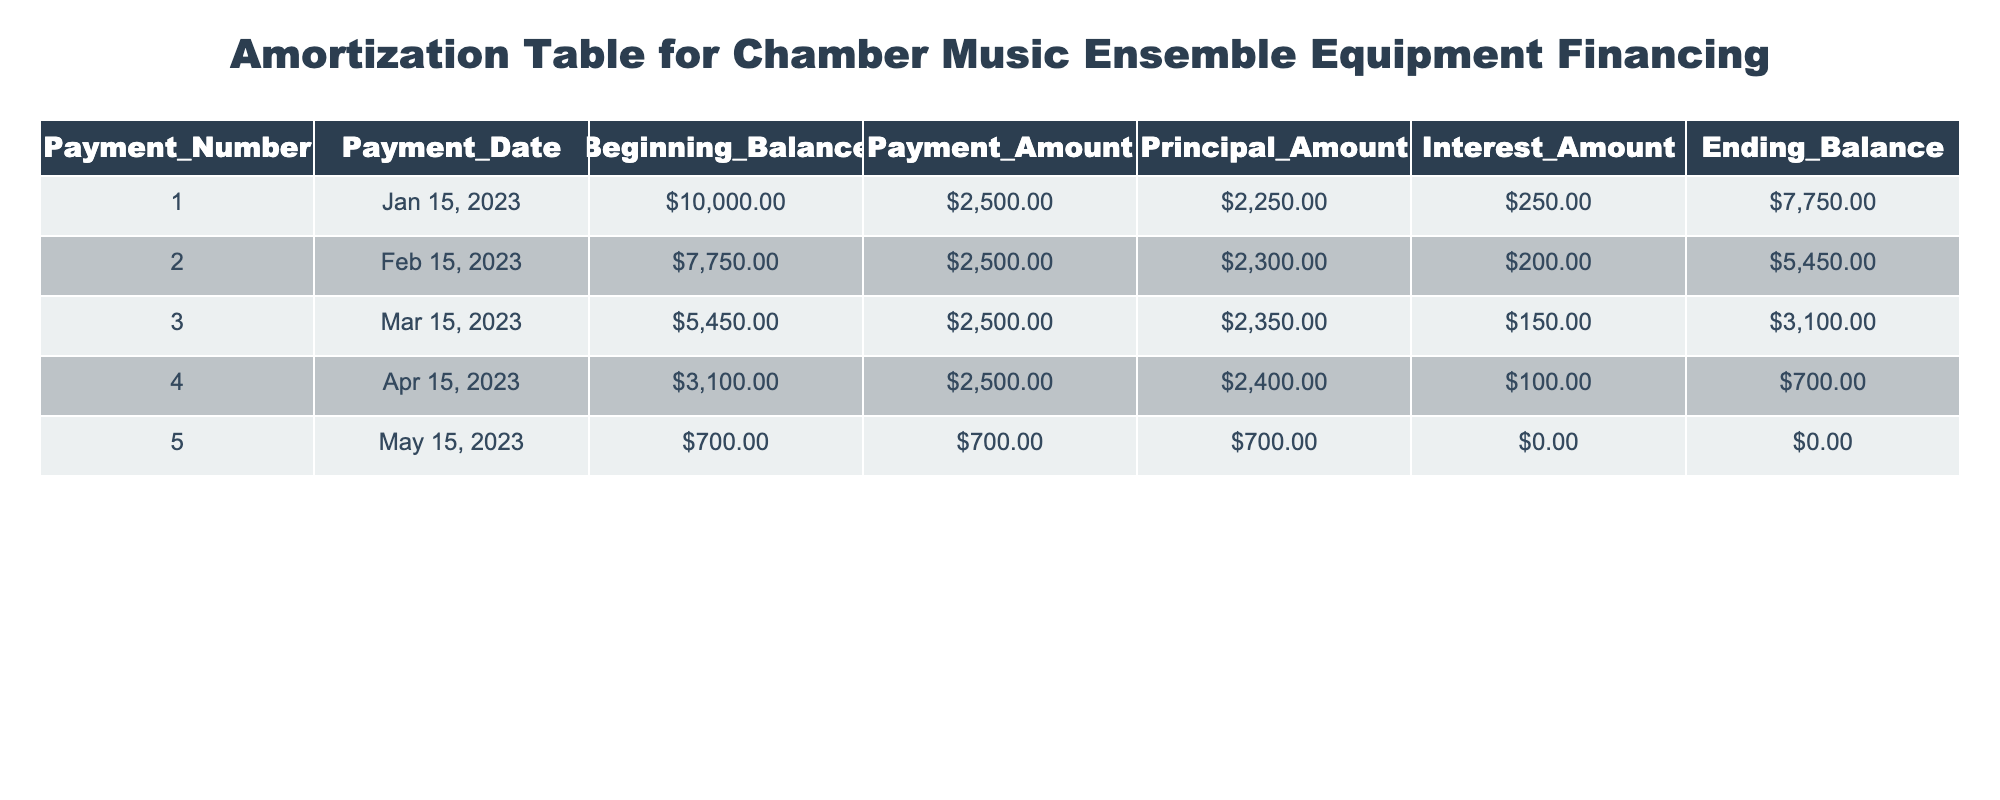What is the payment amount for the third payment? In the table, the payment amount for each entry is listed under the "Payment_Amount" column. By looking at the third row, the payment amount is noted as 2500.00.
Answer: 2500.00 What is the principal amount for the second payment? The principal amount can be found in the "Principal_Amount" column for the second row. It shows that the principal amount is 2300.00.
Answer: 2300.00 What was the ending balance after the first payment? The ending balance after the first payment is displayed in the "Ending_Balance" column for the first row, which indicates it is 7750.00.
Answer: 7750.00 Is the total principal paid after the five payments greater than 10,000? To determine this, we need to sum the principal amounts: 2250 + 2300 + 2350 + 2400 + 700 =  10,000. Since 10,000 is equal to the principal paid, the answer is no.
Answer: No What is the total interest paid across all payments? The total interest paid is calculated by summing the interest amounts from each row: 250 + 200 + 150 + 100 + 0 = 700. Therefore, the total interest paid is 700.
Answer: 700 What is the average ending balance after the three payments? The ending balances after the first three payments are 7750, 5450, and 3100. Adding these balances gives us 7750 + 5450 + 3100 = 16300. Dividing this sum by 3 yields an average of 5433.33.
Answer: 5433.33 Did the interest amount decrease with each successive payment? By examining the "Interest_Amount" column, we find that the amounts decrease from 250 to 200 to 150 to 100 to 0. Thus, this statement is true.
Answer: Yes What was the beginning balance for the fourth payment? The beginning balance is listed under the "Beginning_Balance" column for the fourth row. It shows the beginning balance as 3100.00.
Answer: 3100.00 What is the total of the payment amounts made in January and February? The payment amounts in January and February are both 2500. The total for both months is 2500 + 2500 = 5000.
Answer: 5000 